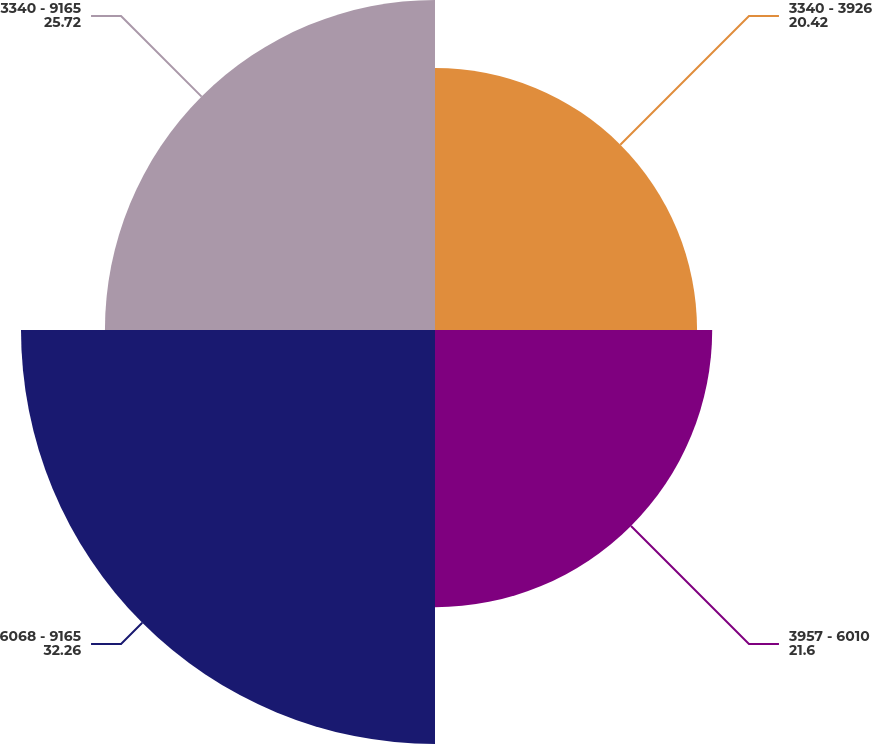Convert chart to OTSL. <chart><loc_0><loc_0><loc_500><loc_500><pie_chart><fcel>3340 - 3926<fcel>3957 - 6010<fcel>6068 - 9165<fcel>3340 - 9165<nl><fcel>20.42%<fcel>21.6%<fcel>32.26%<fcel>25.72%<nl></chart> 